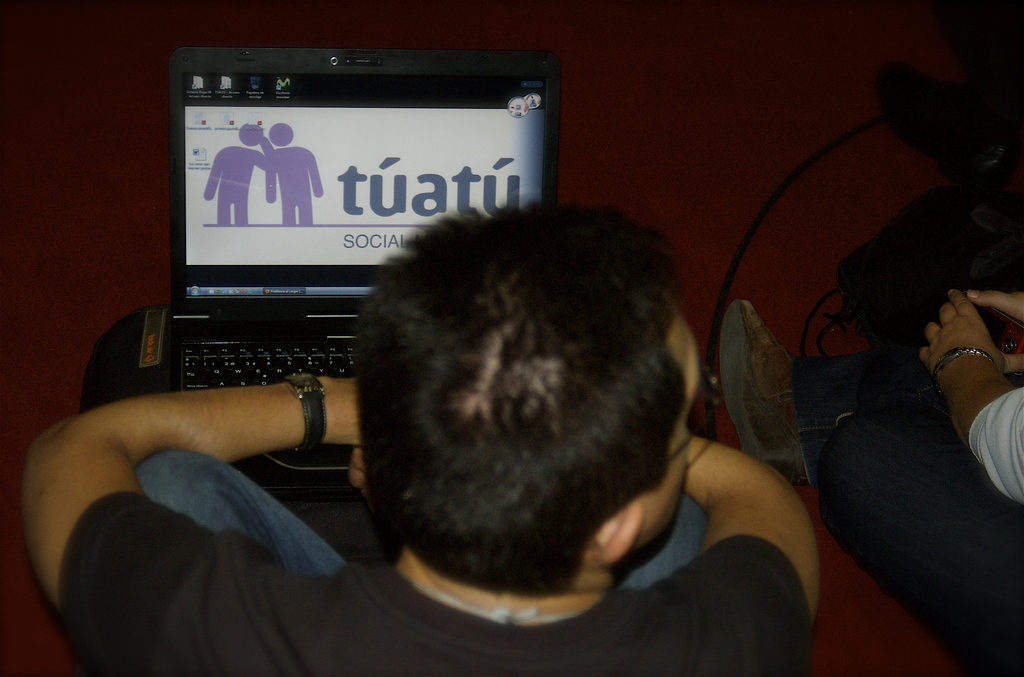Provide a one-sentence caption for the provided image. A young man relaxes while browsing the Tuatu social website on his laptop, seemingly engaged in connecting or learning more about social interactions. 